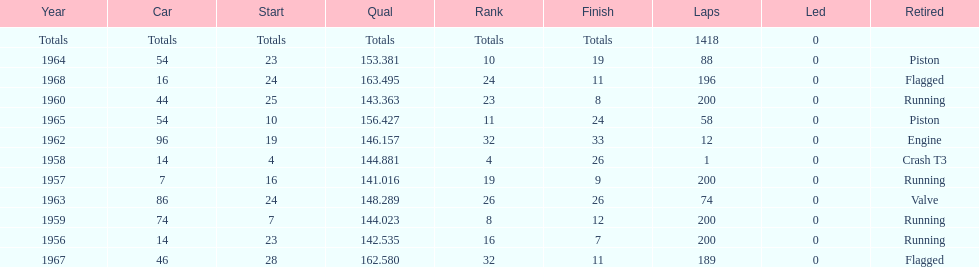How many times was bob veith ranked higher than 10 at an indy 500? 2. 